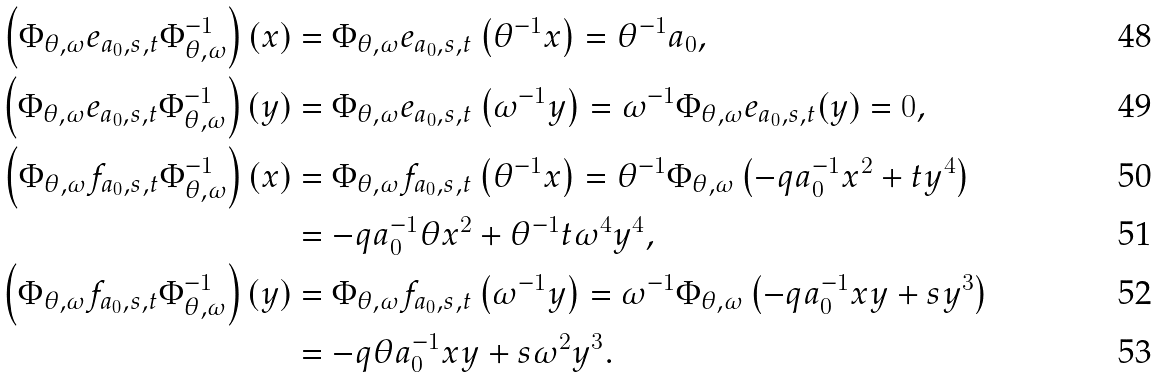<formula> <loc_0><loc_0><loc_500><loc_500>\left ( \Phi _ { \theta , \omega } e _ { a _ { 0 } , s , t } \Phi _ { \theta , \omega } ^ { - 1 } \right ) ( x ) & = \Phi _ { \theta , \omega } e _ { a _ { 0 } , s , t } \left ( \theta ^ { - 1 } x \right ) = \theta ^ { - 1 } a _ { 0 } , \\ \left ( \Phi _ { \theta , \omega } e _ { a _ { 0 } , s , t } \Phi _ { \theta , \omega } ^ { - 1 } \right ) ( y ) & = \Phi _ { \theta , \omega } e _ { a _ { 0 } , s , t } \left ( \omega ^ { - 1 } y \right ) = \omega ^ { - 1 } \Phi _ { \theta , \omega } e _ { a _ { 0 } , s , t } ( y ) = 0 , \\ \left ( \Phi _ { \theta , \omega } f _ { a _ { 0 } , s , t } \Phi _ { \theta , \omega } ^ { - 1 } \right ) ( x ) & = \Phi _ { \theta , \omega } f _ { a _ { 0 } , s , t } \left ( \theta ^ { - 1 } x \right ) = \theta ^ { - 1 } \Phi _ { \theta , \omega } \left ( - q a _ { 0 } ^ { - 1 } x ^ { 2 } + t y ^ { 4 } \right ) \\ & = - q a _ { 0 } ^ { - 1 } \theta x ^ { 2 } + \theta ^ { - 1 } t \omega ^ { 4 } y ^ { 4 } , \\ \left ( \Phi _ { \theta , \omega } f _ { a _ { 0 } , s , t } \Phi _ { \theta , \omega } ^ { - 1 } \right ) ( y ) & = \Phi _ { \theta , \omega } f _ { a _ { 0 } , s , t } \left ( \omega ^ { - 1 } y \right ) = \omega ^ { - 1 } \Phi _ { \theta , \omega } \left ( - q a _ { 0 } ^ { - 1 } x y + s y ^ { 3 } \right ) \\ & = - q \theta a _ { 0 } ^ { - 1 } x y + s \omega ^ { 2 } y ^ { 3 } .</formula> 